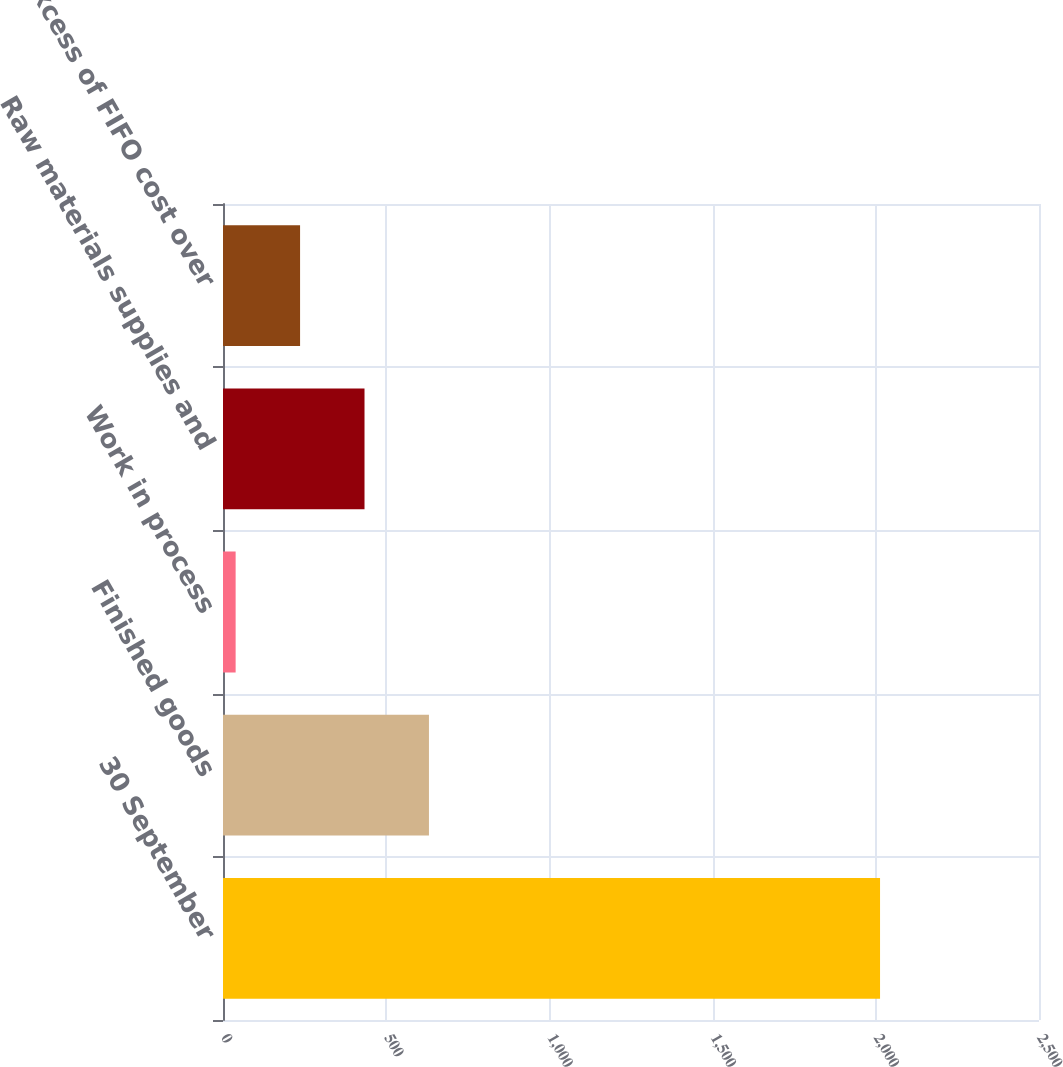Convert chart. <chart><loc_0><loc_0><loc_500><loc_500><bar_chart><fcel>30 September<fcel>Finished goods<fcel>Work in process<fcel>Raw materials supplies and<fcel>Less Excess of FIFO cost over<nl><fcel>2013<fcel>630.99<fcel>38.7<fcel>433.56<fcel>236.13<nl></chart> 